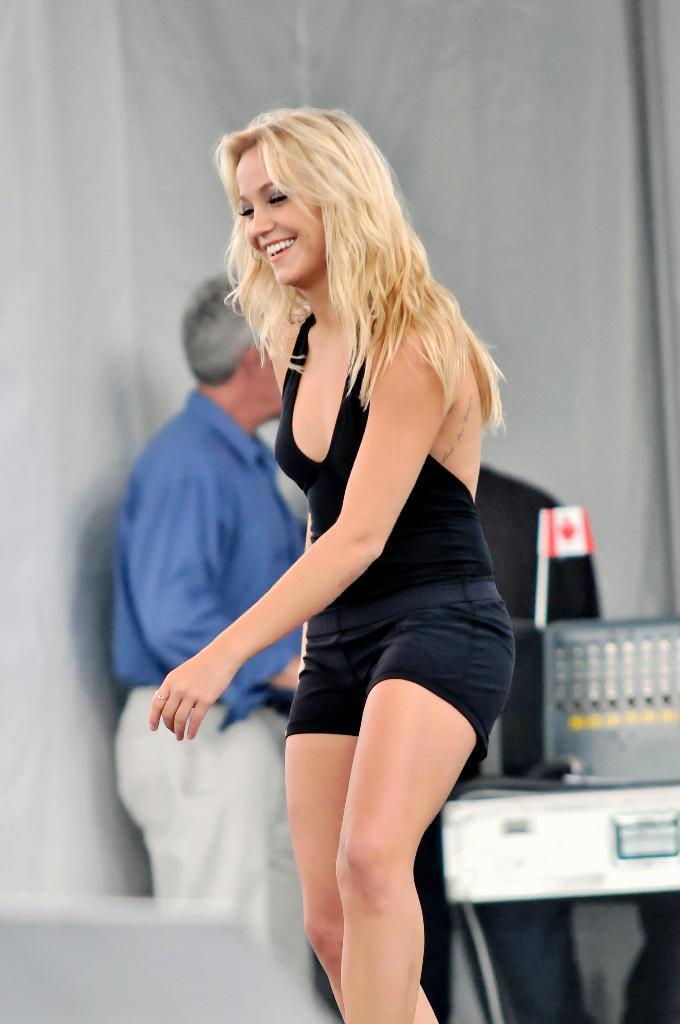Can you describe this image briefly? In this picture we can see a woman smiling and at the back of her we can see a flag, devices, two people standing and in the background we can see curtains. 